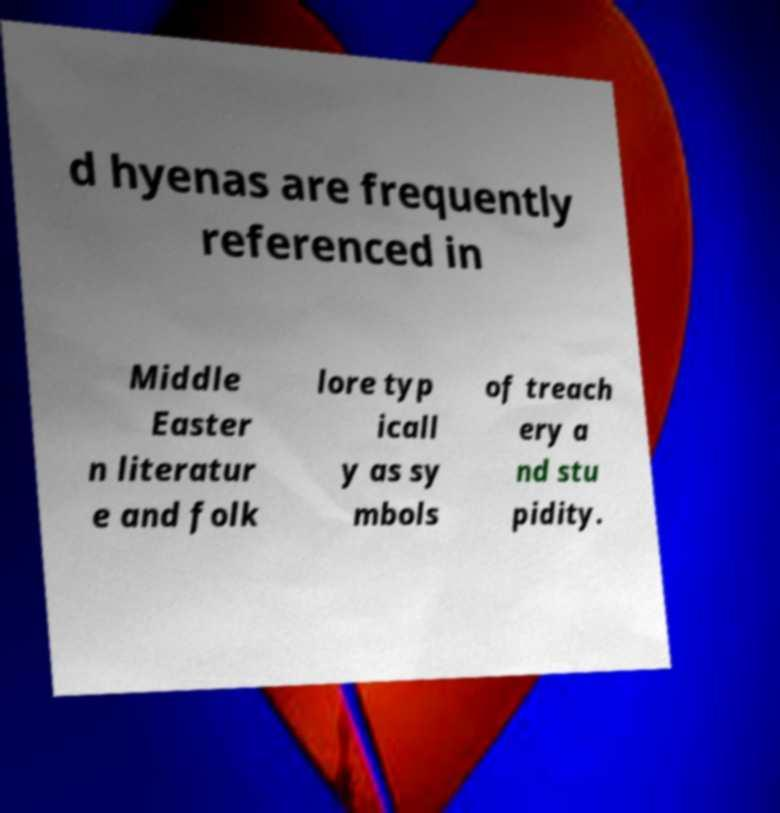Can you accurately transcribe the text from the provided image for me? d hyenas are frequently referenced in Middle Easter n literatur e and folk lore typ icall y as sy mbols of treach ery a nd stu pidity. 